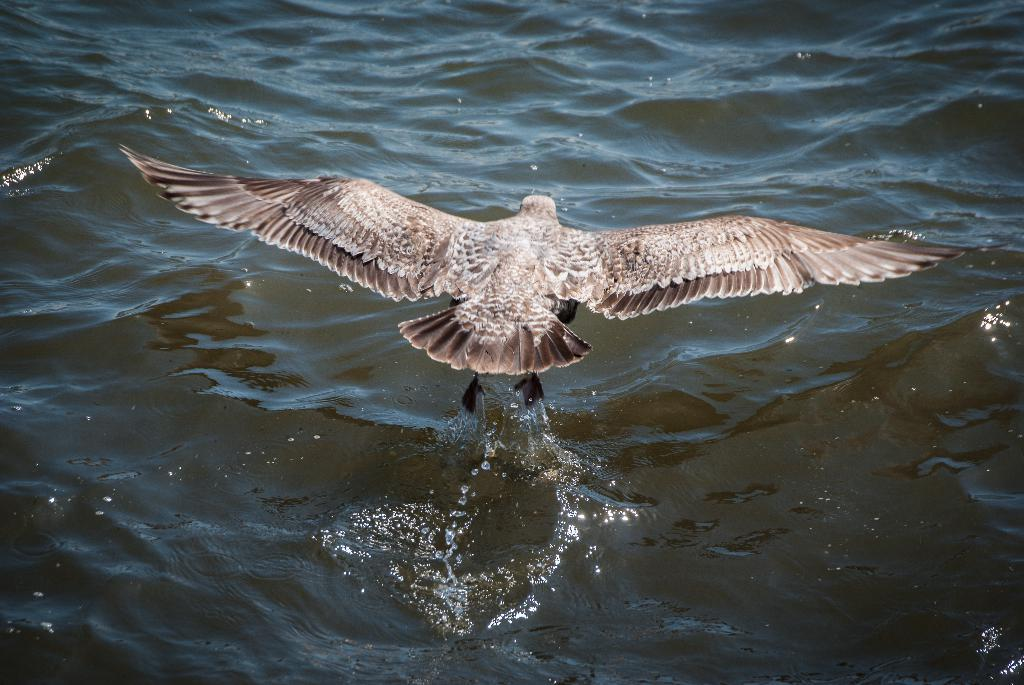What is the primary element visible in the image? There is water in the image. What type of animal can be seen in the image? There is a bird flying in the image. What scent can be detected from the water in the image? There is no information about the scent of the water in the image, as it is not mentioned in the provided facts. Are there any giants present in the image? There is no mention of giants in the image, so we cannot confirm their presence. 